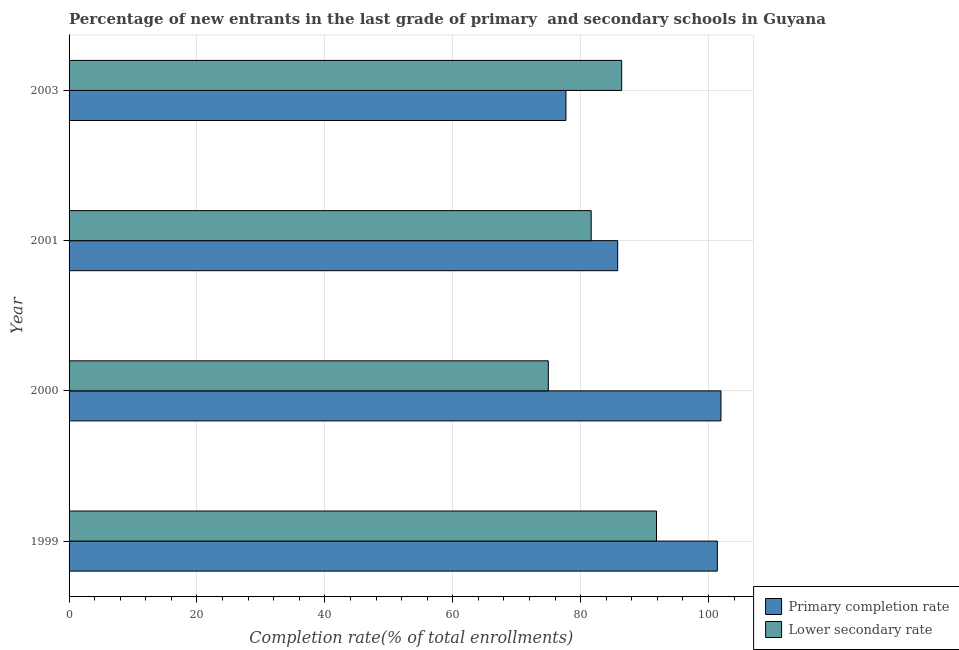How many different coloured bars are there?
Your response must be concise. 2. How many groups of bars are there?
Your response must be concise. 4. Are the number of bars on each tick of the Y-axis equal?
Your answer should be very brief. Yes. In how many cases, is the number of bars for a given year not equal to the number of legend labels?
Ensure brevity in your answer.  0. What is the completion rate in primary schools in 1999?
Give a very brief answer. 101.37. Across all years, what is the maximum completion rate in primary schools?
Provide a succinct answer. 101.94. Across all years, what is the minimum completion rate in secondary schools?
Offer a terse response. 74.94. In which year was the completion rate in secondary schools maximum?
Offer a very short reply. 1999. In which year was the completion rate in primary schools minimum?
Offer a very short reply. 2003. What is the total completion rate in primary schools in the graph?
Offer a terse response. 366.8. What is the difference between the completion rate in primary schools in 2000 and that in 2001?
Your answer should be very brief. 16.16. What is the difference between the completion rate in primary schools in 2000 and the completion rate in secondary schools in 2001?
Give a very brief answer. 20.3. What is the average completion rate in primary schools per year?
Provide a short and direct response. 91.7. In the year 2000, what is the difference between the completion rate in secondary schools and completion rate in primary schools?
Your answer should be very brief. -27. In how many years, is the completion rate in secondary schools greater than 12 %?
Make the answer very short. 4. What is the ratio of the completion rate in primary schools in 2001 to that in 2003?
Keep it short and to the point. 1.1. What is the difference between the highest and the second highest completion rate in primary schools?
Your answer should be compact. 0.57. What is the difference between the highest and the lowest completion rate in secondary schools?
Your answer should be compact. 16.92. What does the 2nd bar from the top in 2000 represents?
Make the answer very short. Primary completion rate. What does the 2nd bar from the bottom in 2000 represents?
Ensure brevity in your answer.  Lower secondary rate. How many years are there in the graph?
Your answer should be very brief. 4. What is the difference between two consecutive major ticks on the X-axis?
Your answer should be compact. 20. Are the values on the major ticks of X-axis written in scientific E-notation?
Your response must be concise. No. Does the graph contain any zero values?
Your answer should be very brief. No. Where does the legend appear in the graph?
Your answer should be very brief. Bottom right. How are the legend labels stacked?
Your answer should be compact. Vertical. What is the title of the graph?
Your answer should be compact. Percentage of new entrants in the last grade of primary  and secondary schools in Guyana. Does "Quasi money growth" appear as one of the legend labels in the graph?
Your answer should be compact. No. What is the label or title of the X-axis?
Ensure brevity in your answer.  Completion rate(% of total enrollments). What is the label or title of the Y-axis?
Your answer should be compact. Year. What is the Completion rate(% of total enrollments) in Primary completion rate in 1999?
Your response must be concise. 101.37. What is the Completion rate(% of total enrollments) of Lower secondary rate in 1999?
Give a very brief answer. 91.86. What is the Completion rate(% of total enrollments) of Primary completion rate in 2000?
Your response must be concise. 101.94. What is the Completion rate(% of total enrollments) in Lower secondary rate in 2000?
Offer a terse response. 74.94. What is the Completion rate(% of total enrollments) of Primary completion rate in 2001?
Make the answer very short. 85.79. What is the Completion rate(% of total enrollments) in Lower secondary rate in 2001?
Offer a very short reply. 81.64. What is the Completion rate(% of total enrollments) of Primary completion rate in 2003?
Provide a short and direct response. 77.7. What is the Completion rate(% of total enrollments) of Lower secondary rate in 2003?
Your answer should be very brief. 86.41. Across all years, what is the maximum Completion rate(% of total enrollments) of Primary completion rate?
Your response must be concise. 101.94. Across all years, what is the maximum Completion rate(% of total enrollments) of Lower secondary rate?
Offer a terse response. 91.86. Across all years, what is the minimum Completion rate(% of total enrollments) in Primary completion rate?
Offer a very short reply. 77.7. Across all years, what is the minimum Completion rate(% of total enrollments) of Lower secondary rate?
Give a very brief answer. 74.94. What is the total Completion rate(% of total enrollments) in Primary completion rate in the graph?
Give a very brief answer. 366.8. What is the total Completion rate(% of total enrollments) in Lower secondary rate in the graph?
Your answer should be very brief. 334.86. What is the difference between the Completion rate(% of total enrollments) of Primary completion rate in 1999 and that in 2000?
Provide a succinct answer. -0.57. What is the difference between the Completion rate(% of total enrollments) in Lower secondary rate in 1999 and that in 2000?
Ensure brevity in your answer.  16.92. What is the difference between the Completion rate(% of total enrollments) in Primary completion rate in 1999 and that in 2001?
Your answer should be very brief. 15.59. What is the difference between the Completion rate(% of total enrollments) of Lower secondary rate in 1999 and that in 2001?
Offer a very short reply. 10.22. What is the difference between the Completion rate(% of total enrollments) of Primary completion rate in 1999 and that in 2003?
Make the answer very short. 23.67. What is the difference between the Completion rate(% of total enrollments) in Lower secondary rate in 1999 and that in 2003?
Offer a very short reply. 5.45. What is the difference between the Completion rate(% of total enrollments) of Primary completion rate in 2000 and that in 2001?
Keep it short and to the point. 16.16. What is the difference between the Completion rate(% of total enrollments) of Lower secondary rate in 2000 and that in 2001?
Give a very brief answer. -6.7. What is the difference between the Completion rate(% of total enrollments) of Primary completion rate in 2000 and that in 2003?
Offer a terse response. 24.24. What is the difference between the Completion rate(% of total enrollments) of Lower secondary rate in 2000 and that in 2003?
Your response must be concise. -11.47. What is the difference between the Completion rate(% of total enrollments) of Primary completion rate in 2001 and that in 2003?
Keep it short and to the point. 8.09. What is the difference between the Completion rate(% of total enrollments) in Lower secondary rate in 2001 and that in 2003?
Your answer should be very brief. -4.77. What is the difference between the Completion rate(% of total enrollments) of Primary completion rate in 1999 and the Completion rate(% of total enrollments) of Lower secondary rate in 2000?
Make the answer very short. 26.43. What is the difference between the Completion rate(% of total enrollments) in Primary completion rate in 1999 and the Completion rate(% of total enrollments) in Lower secondary rate in 2001?
Give a very brief answer. 19.73. What is the difference between the Completion rate(% of total enrollments) of Primary completion rate in 1999 and the Completion rate(% of total enrollments) of Lower secondary rate in 2003?
Keep it short and to the point. 14.96. What is the difference between the Completion rate(% of total enrollments) of Primary completion rate in 2000 and the Completion rate(% of total enrollments) of Lower secondary rate in 2001?
Give a very brief answer. 20.3. What is the difference between the Completion rate(% of total enrollments) of Primary completion rate in 2000 and the Completion rate(% of total enrollments) of Lower secondary rate in 2003?
Your answer should be compact. 15.53. What is the difference between the Completion rate(% of total enrollments) of Primary completion rate in 2001 and the Completion rate(% of total enrollments) of Lower secondary rate in 2003?
Your answer should be compact. -0.63. What is the average Completion rate(% of total enrollments) of Primary completion rate per year?
Your response must be concise. 91.7. What is the average Completion rate(% of total enrollments) in Lower secondary rate per year?
Your answer should be very brief. 83.71. In the year 1999, what is the difference between the Completion rate(% of total enrollments) of Primary completion rate and Completion rate(% of total enrollments) of Lower secondary rate?
Ensure brevity in your answer.  9.51. In the year 2000, what is the difference between the Completion rate(% of total enrollments) in Primary completion rate and Completion rate(% of total enrollments) in Lower secondary rate?
Offer a terse response. 27. In the year 2001, what is the difference between the Completion rate(% of total enrollments) of Primary completion rate and Completion rate(% of total enrollments) of Lower secondary rate?
Provide a short and direct response. 4.14. In the year 2003, what is the difference between the Completion rate(% of total enrollments) of Primary completion rate and Completion rate(% of total enrollments) of Lower secondary rate?
Keep it short and to the point. -8.71. What is the ratio of the Completion rate(% of total enrollments) of Lower secondary rate in 1999 to that in 2000?
Offer a very short reply. 1.23. What is the ratio of the Completion rate(% of total enrollments) in Primary completion rate in 1999 to that in 2001?
Your response must be concise. 1.18. What is the ratio of the Completion rate(% of total enrollments) of Lower secondary rate in 1999 to that in 2001?
Make the answer very short. 1.13. What is the ratio of the Completion rate(% of total enrollments) in Primary completion rate in 1999 to that in 2003?
Give a very brief answer. 1.3. What is the ratio of the Completion rate(% of total enrollments) in Lower secondary rate in 1999 to that in 2003?
Provide a short and direct response. 1.06. What is the ratio of the Completion rate(% of total enrollments) in Primary completion rate in 2000 to that in 2001?
Your answer should be compact. 1.19. What is the ratio of the Completion rate(% of total enrollments) in Lower secondary rate in 2000 to that in 2001?
Provide a short and direct response. 0.92. What is the ratio of the Completion rate(% of total enrollments) of Primary completion rate in 2000 to that in 2003?
Make the answer very short. 1.31. What is the ratio of the Completion rate(% of total enrollments) in Lower secondary rate in 2000 to that in 2003?
Offer a terse response. 0.87. What is the ratio of the Completion rate(% of total enrollments) of Primary completion rate in 2001 to that in 2003?
Your response must be concise. 1.1. What is the ratio of the Completion rate(% of total enrollments) in Lower secondary rate in 2001 to that in 2003?
Give a very brief answer. 0.94. What is the difference between the highest and the second highest Completion rate(% of total enrollments) in Primary completion rate?
Ensure brevity in your answer.  0.57. What is the difference between the highest and the second highest Completion rate(% of total enrollments) of Lower secondary rate?
Ensure brevity in your answer.  5.45. What is the difference between the highest and the lowest Completion rate(% of total enrollments) of Primary completion rate?
Provide a succinct answer. 24.24. What is the difference between the highest and the lowest Completion rate(% of total enrollments) in Lower secondary rate?
Offer a terse response. 16.92. 